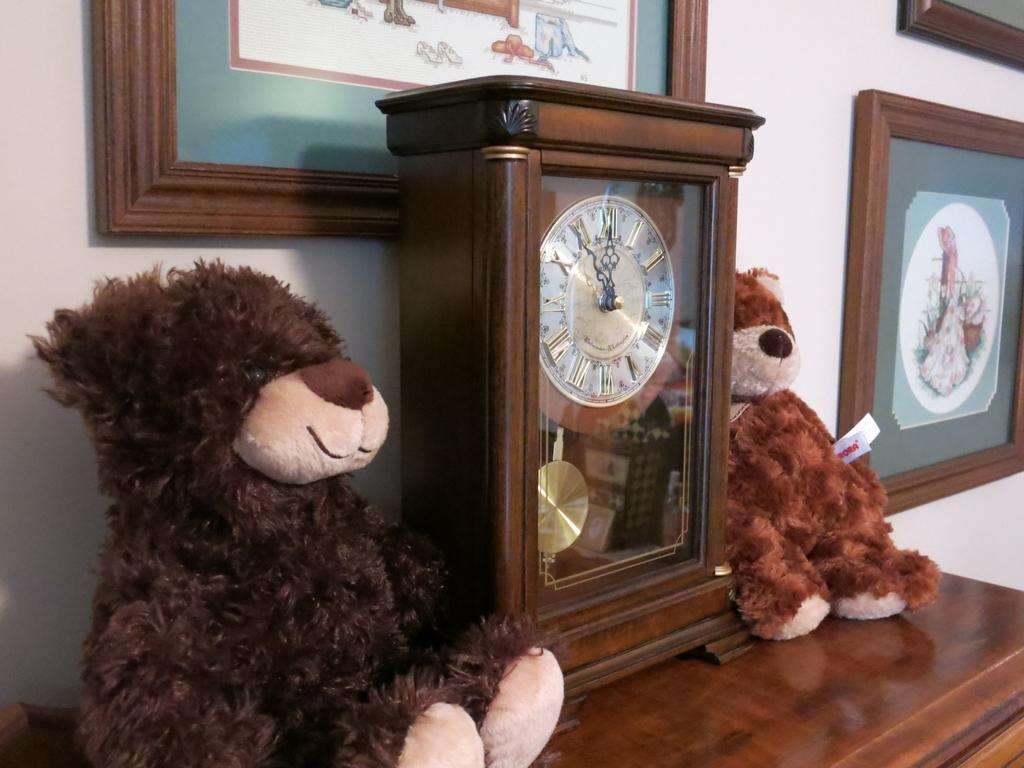What type of objects are on the table in the image? There are teddy bears and a pendulum clock on the table in the image. What else can be seen in the image besides the teddy bears and pendulum clock? There are photo frames visible in the image. What type of brick is used to build the beast in the image? There is no beast or brick present in the image; it features teddy bears, a pendulum clock, and photo frames. 